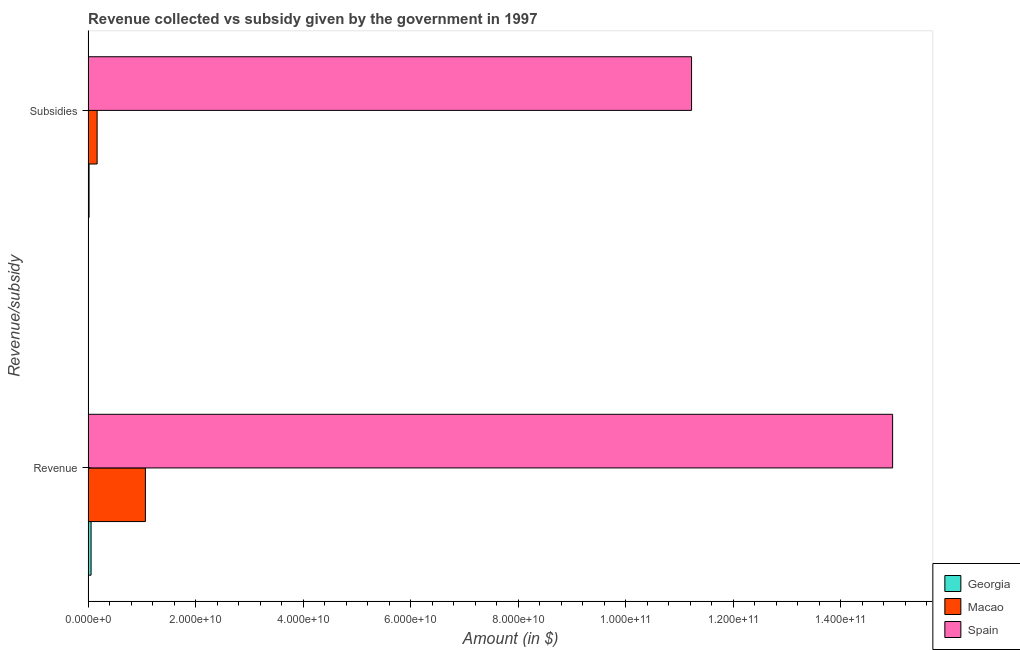How many different coloured bars are there?
Your answer should be compact. 3. How many groups of bars are there?
Your answer should be compact. 2. How many bars are there on the 2nd tick from the top?
Provide a short and direct response. 3. How many bars are there on the 1st tick from the bottom?
Ensure brevity in your answer.  3. What is the label of the 1st group of bars from the top?
Offer a terse response. Subsidies. What is the amount of revenue collected in Macao?
Provide a succinct answer. 1.07e+1. Across all countries, what is the maximum amount of revenue collected?
Ensure brevity in your answer.  1.50e+11. Across all countries, what is the minimum amount of revenue collected?
Your answer should be very brief. 5.56e+08. In which country was the amount of revenue collected maximum?
Ensure brevity in your answer.  Spain. In which country was the amount of revenue collected minimum?
Your response must be concise. Georgia. What is the total amount of subsidies given in the graph?
Your answer should be very brief. 1.14e+11. What is the difference between the amount of revenue collected in Georgia and that in Spain?
Provide a succinct answer. -1.49e+11. What is the difference between the amount of revenue collected in Macao and the amount of subsidies given in Georgia?
Ensure brevity in your answer.  1.05e+1. What is the average amount of subsidies given per country?
Ensure brevity in your answer.  3.80e+1. What is the difference between the amount of subsidies given and amount of revenue collected in Georgia?
Keep it short and to the point. -3.72e+08. In how many countries, is the amount of subsidies given greater than 112000000000 $?
Offer a very short reply. 1. What is the ratio of the amount of subsidies given in Spain to that in Macao?
Your response must be concise. 66.77. Is the amount of subsidies given in Georgia less than that in Macao?
Give a very brief answer. Yes. In how many countries, is the amount of revenue collected greater than the average amount of revenue collected taken over all countries?
Make the answer very short. 1. What does the 2nd bar from the top in Subsidies represents?
Your answer should be compact. Macao. What does the 2nd bar from the bottom in Subsidies represents?
Offer a very short reply. Macao. Are all the bars in the graph horizontal?
Make the answer very short. Yes. How many countries are there in the graph?
Ensure brevity in your answer.  3. Does the graph contain any zero values?
Your response must be concise. No. Does the graph contain grids?
Ensure brevity in your answer.  No. Where does the legend appear in the graph?
Ensure brevity in your answer.  Bottom right. What is the title of the graph?
Keep it short and to the point. Revenue collected vs subsidy given by the government in 1997. What is the label or title of the X-axis?
Your answer should be very brief. Amount (in $). What is the label or title of the Y-axis?
Keep it short and to the point. Revenue/subsidy. What is the Amount (in $) in Georgia in Revenue?
Provide a succinct answer. 5.56e+08. What is the Amount (in $) in Macao in Revenue?
Make the answer very short. 1.07e+1. What is the Amount (in $) in Spain in Revenue?
Provide a short and direct response. 1.50e+11. What is the Amount (in $) in Georgia in Subsidies?
Offer a very short reply. 1.84e+08. What is the Amount (in $) of Macao in Subsidies?
Your answer should be compact. 1.68e+09. What is the Amount (in $) in Spain in Subsidies?
Provide a succinct answer. 1.12e+11. Across all Revenue/subsidy, what is the maximum Amount (in $) of Georgia?
Ensure brevity in your answer.  5.56e+08. Across all Revenue/subsidy, what is the maximum Amount (in $) in Macao?
Keep it short and to the point. 1.07e+1. Across all Revenue/subsidy, what is the maximum Amount (in $) in Spain?
Give a very brief answer. 1.50e+11. Across all Revenue/subsidy, what is the minimum Amount (in $) in Georgia?
Offer a very short reply. 1.84e+08. Across all Revenue/subsidy, what is the minimum Amount (in $) in Macao?
Keep it short and to the point. 1.68e+09. Across all Revenue/subsidy, what is the minimum Amount (in $) of Spain?
Keep it short and to the point. 1.12e+11. What is the total Amount (in $) in Georgia in the graph?
Keep it short and to the point. 7.40e+08. What is the total Amount (in $) in Macao in the graph?
Provide a succinct answer. 1.23e+1. What is the total Amount (in $) of Spain in the graph?
Keep it short and to the point. 2.62e+11. What is the difference between the Amount (in $) in Georgia in Revenue and that in Subsidies?
Your response must be concise. 3.72e+08. What is the difference between the Amount (in $) in Macao in Revenue and that in Subsidies?
Your answer should be very brief. 8.98e+09. What is the difference between the Amount (in $) of Spain in Revenue and that in Subsidies?
Your answer should be compact. 3.74e+1. What is the difference between the Amount (in $) of Georgia in Revenue and the Amount (in $) of Macao in Subsidies?
Make the answer very short. -1.13e+09. What is the difference between the Amount (in $) of Georgia in Revenue and the Amount (in $) of Spain in Subsidies?
Your answer should be compact. -1.12e+11. What is the difference between the Amount (in $) in Macao in Revenue and the Amount (in $) in Spain in Subsidies?
Your response must be concise. -1.02e+11. What is the average Amount (in $) in Georgia per Revenue/subsidy?
Make the answer very short. 3.70e+08. What is the average Amount (in $) in Macao per Revenue/subsidy?
Keep it short and to the point. 6.17e+09. What is the average Amount (in $) of Spain per Revenue/subsidy?
Offer a terse response. 1.31e+11. What is the difference between the Amount (in $) in Georgia and Amount (in $) in Macao in Revenue?
Your answer should be very brief. -1.01e+1. What is the difference between the Amount (in $) of Georgia and Amount (in $) of Spain in Revenue?
Your answer should be compact. -1.49e+11. What is the difference between the Amount (in $) of Macao and Amount (in $) of Spain in Revenue?
Offer a very short reply. -1.39e+11. What is the difference between the Amount (in $) in Georgia and Amount (in $) in Macao in Subsidies?
Ensure brevity in your answer.  -1.50e+09. What is the difference between the Amount (in $) of Georgia and Amount (in $) of Spain in Subsidies?
Offer a terse response. -1.12e+11. What is the difference between the Amount (in $) in Macao and Amount (in $) in Spain in Subsidies?
Provide a succinct answer. -1.11e+11. What is the ratio of the Amount (in $) in Georgia in Revenue to that in Subsidies?
Make the answer very short. 3.02. What is the ratio of the Amount (in $) of Macao in Revenue to that in Subsidies?
Keep it short and to the point. 6.34. What is the ratio of the Amount (in $) in Spain in Revenue to that in Subsidies?
Your answer should be compact. 1.33. What is the difference between the highest and the second highest Amount (in $) of Georgia?
Offer a terse response. 3.72e+08. What is the difference between the highest and the second highest Amount (in $) in Macao?
Provide a succinct answer. 8.98e+09. What is the difference between the highest and the second highest Amount (in $) of Spain?
Offer a terse response. 3.74e+1. What is the difference between the highest and the lowest Amount (in $) of Georgia?
Offer a very short reply. 3.72e+08. What is the difference between the highest and the lowest Amount (in $) in Macao?
Offer a very short reply. 8.98e+09. What is the difference between the highest and the lowest Amount (in $) of Spain?
Your response must be concise. 3.74e+1. 